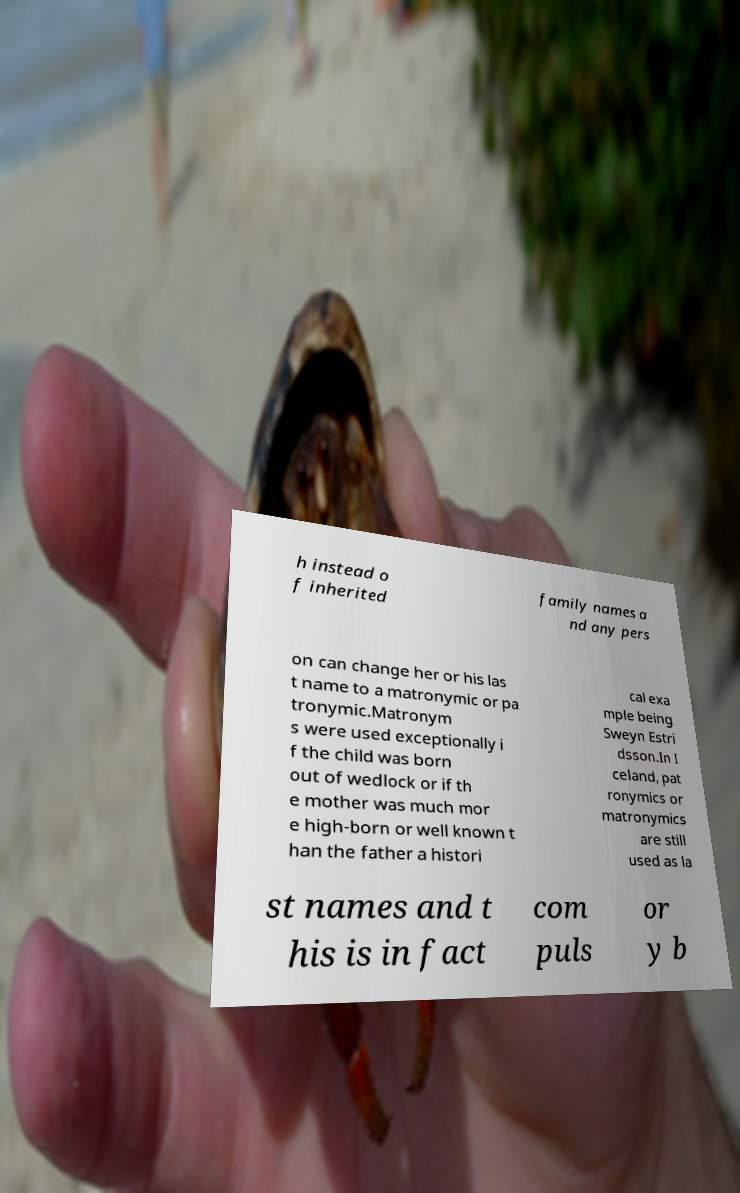Can you accurately transcribe the text from the provided image for me? h instead o f inherited family names a nd any pers on can change her or his las t name to a matronymic or pa tronymic.Matronym s were used exceptionally i f the child was born out of wedlock or if th e mother was much mor e high-born or well known t han the father a histori cal exa mple being Sweyn Estri dsson.In I celand, pat ronymics or matronymics are still used as la st names and t his is in fact com puls or y b 